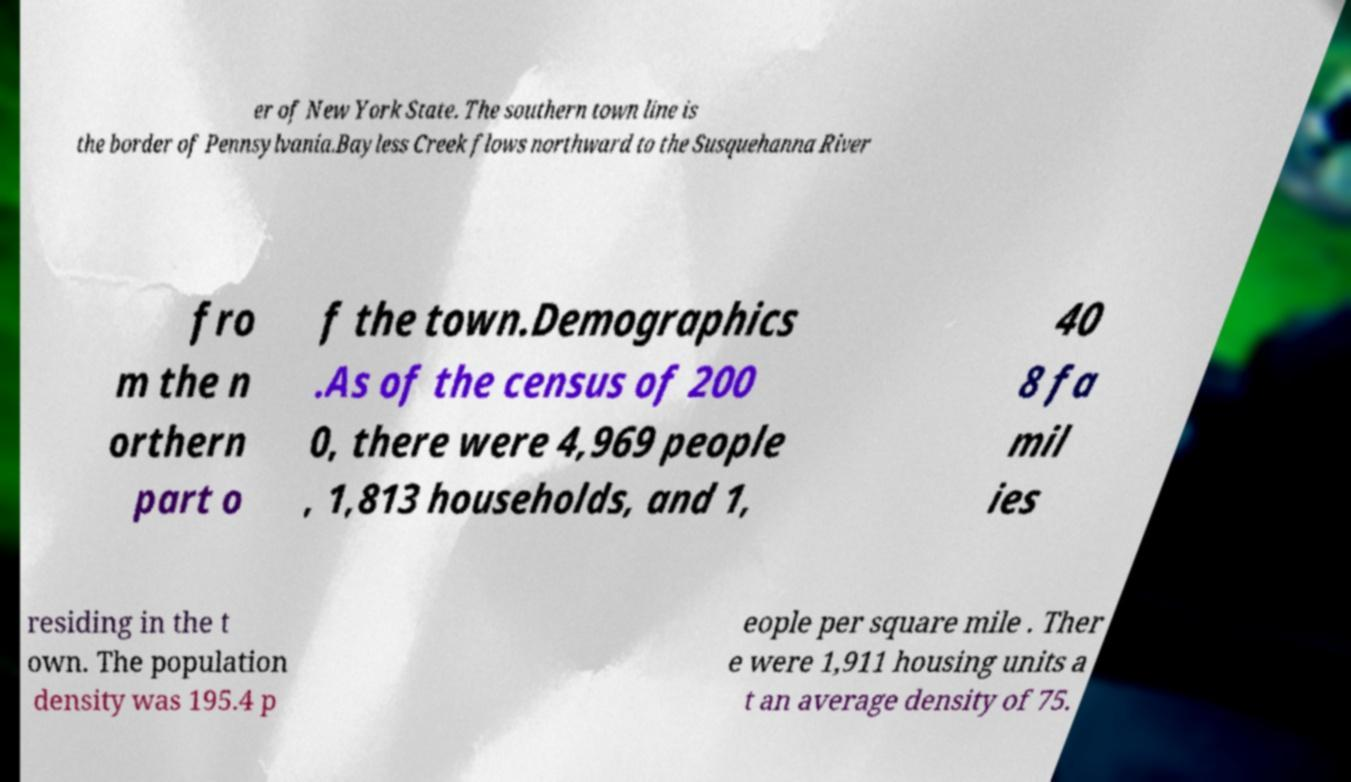Please identify and transcribe the text found in this image. er of New York State. The southern town line is the border of Pennsylvania.Bayless Creek flows northward to the Susquehanna River fro m the n orthern part o f the town.Demographics .As of the census of 200 0, there were 4,969 people , 1,813 households, and 1, 40 8 fa mil ies residing in the t own. The population density was 195.4 p eople per square mile . Ther e were 1,911 housing units a t an average density of 75. 